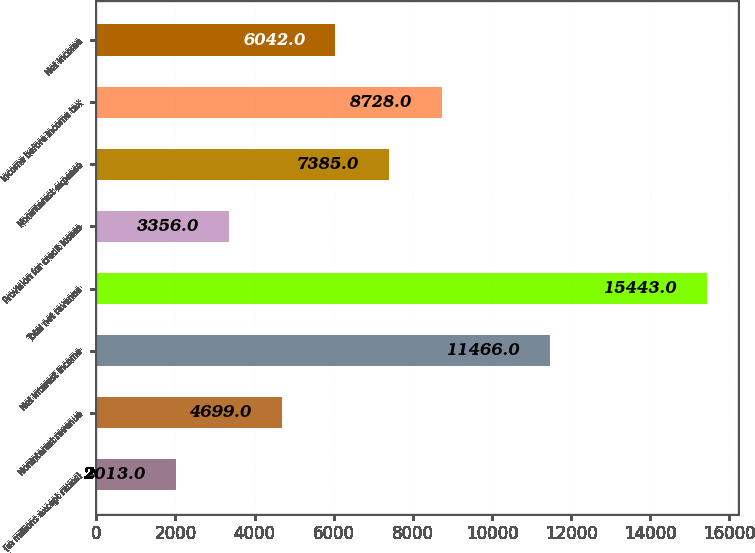<chart> <loc_0><loc_0><loc_500><loc_500><bar_chart><fcel>(in millions except ratios)<fcel>Noninterest revenue<fcel>Net interest income<fcel>Total net revenue<fcel>Provision for credit losses<fcel>Noninterest expense<fcel>Income before income tax<fcel>Net income<nl><fcel>2013<fcel>4699<fcel>11466<fcel>15443<fcel>3356<fcel>7385<fcel>8728<fcel>6042<nl></chart> 